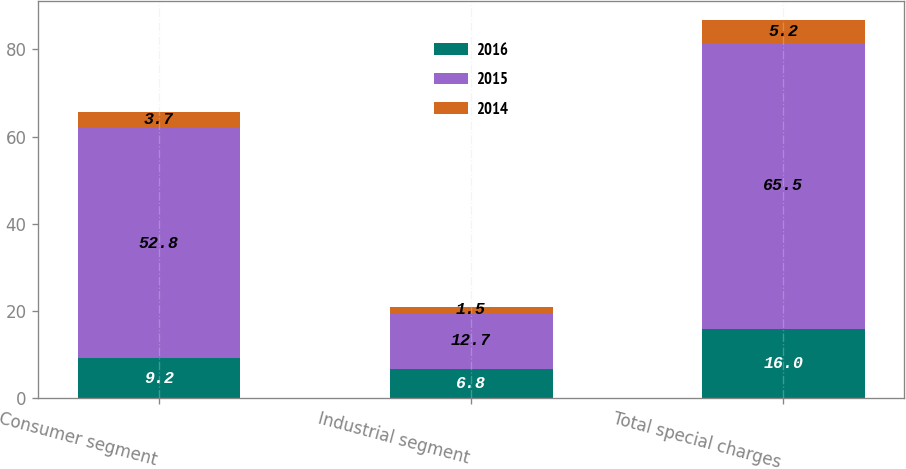Convert chart to OTSL. <chart><loc_0><loc_0><loc_500><loc_500><stacked_bar_chart><ecel><fcel>Consumer segment<fcel>Industrial segment<fcel>Total special charges<nl><fcel>2016<fcel>9.2<fcel>6.8<fcel>16<nl><fcel>2015<fcel>52.8<fcel>12.7<fcel>65.5<nl><fcel>2014<fcel>3.7<fcel>1.5<fcel>5.2<nl></chart> 